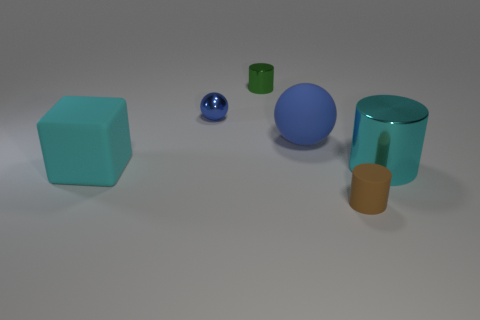Add 3 large brown rubber cylinders. How many objects exist? 9 Subtract all spheres. How many objects are left? 4 Subtract 0 yellow blocks. How many objects are left? 6 Subtract all tiny cylinders. Subtract all large cyan cylinders. How many objects are left? 3 Add 3 large things. How many large things are left? 6 Add 6 tiny cyan shiny cubes. How many tiny cyan shiny cubes exist? 6 